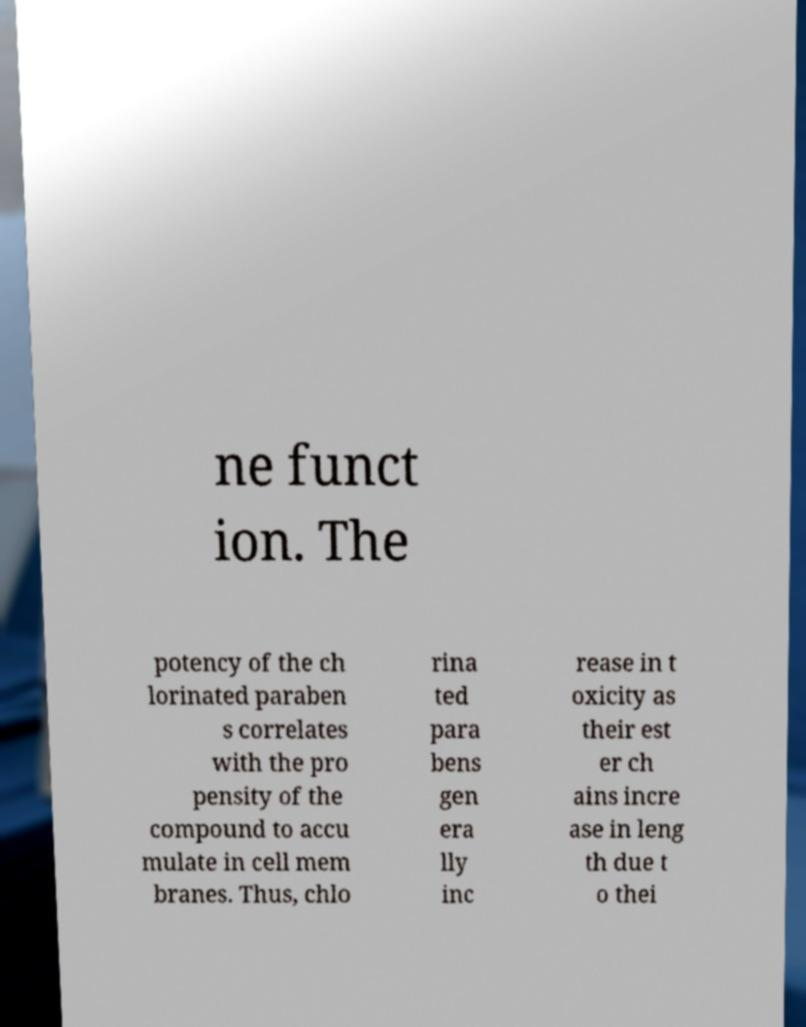I need the written content from this picture converted into text. Can you do that? ne funct ion. The potency of the ch lorinated paraben s correlates with the pro pensity of the compound to accu mulate in cell mem branes. Thus, chlo rina ted para bens gen era lly inc rease in t oxicity as their est er ch ains incre ase in leng th due t o thei 